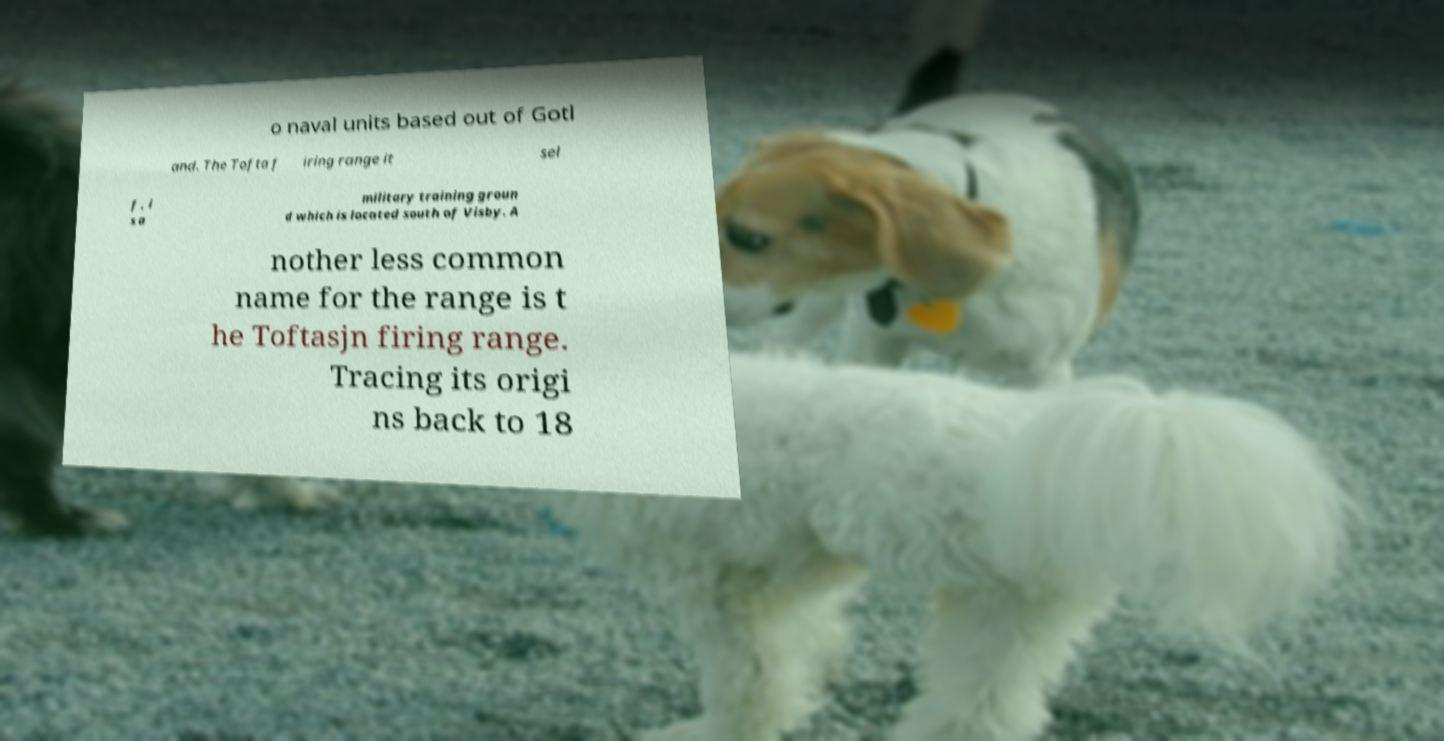Please read and relay the text visible in this image. What does it say? o naval units based out of Gotl and. The Tofta f iring range it sel f , i s a military training groun d which is located south of Visby. A nother less common name for the range is t he Toftasjn firing range. Tracing its origi ns back to 18 